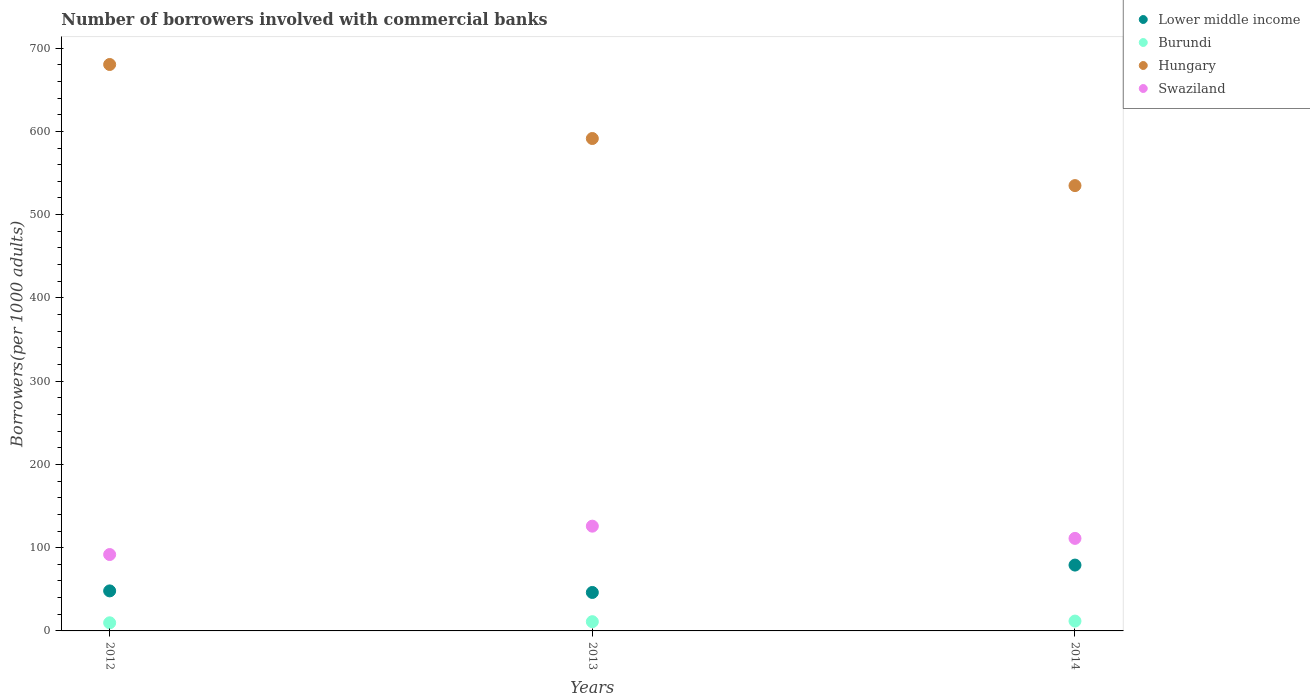What is the number of borrowers involved with commercial banks in Burundi in 2013?
Ensure brevity in your answer.  11.09. Across all years, what is the maximum number of borrowers involved with commercial banks in Lower middle income?
Provide a succinct answer. 79.08. Across all years, what is the minimum number of borrowers involved with commercial banks in Hungary?
Make the answer very short. 534.85. In which year was the number of borrowers involved with commercial banks in Swaziland minimum?
Your response must be concise. 2012. What is the total number of borrowers involved with commercial banks in Hungary in the graph?
Ensure brevity in your answer.  1806.59. What is the difference between the number of borrowers involved with commercial banks in Swaziland in 2012 and that in 2014?
Offer a very short reply. -19.4. What is the difference between the number of borrowers involved with commercial banks in Lower middle income in 2013 and the number of borrowers involved with commercial banks in Hungary in 2012?
Ensure brevity in your answer.  -634.13. What is the average number of borrowers involved with commercial banks in Hungary per year?
Your response must be concise. 602.2. In the year 2012, what is the difference between the number of borrowers involved with commercial banks in Burundi and number of borrowers involved with commercial banks in Hungary?
Provide a short and direct response. -670.57. In how many years, is the number of borrowers involved with commercial banks in Burundi greater than 320?
Ensure brevity in your answer.  0. What is the ratio of the number of borrowers involved with commercial banks in Hungary in 2012 to that in 2014?
Offer a very short reply. 1.27. Is the number of borrowers involved with commercial banks in Lower middle income in 2013 less than that in 2014?
Your answer should be very brief. Yes. Is the difference between the number of borrowers involved with commercial banks in Burundi in 2012 and 2013 greater than the difference between the number of borrowers involved with commercial banks in Hungary in 2012 and 2013?
Make the answer very short. No. What is the difference between the highest and the second highest number of borrowers involved with commercial banks in Burundi?
Your answer should be compact. 0.73. What is the difference between the highest and the lowest number of borrowers involved with commercial banks in Burundi?
Provide a short and direct response. 2.07. In how many years, is the number of borrowers involved with commercial banks in Lower middle income greater than the average number of borrowers involved with commercial banks in Lower middle income taken over all years?
Your answer should be very brief. 1. Is the sum of the number of borrowers involved with commercial banks in Swaziland in 2012 and 2014 greater than the maximum number of borrowers involved with commercial banks in Hungary across all years?
Ensure brevity in your answer.  No. Is it the case that in every year, the sum of the number of borrowers involved with commercial banks in Burundi and number of borrowers involved with commercial banks in Hungary  is greater than the number of borrowers involved with commercial banks in Swaziland?
Keep it short and to the point. Yes. Does the number of borrowers involved with commercial banks in Lower middle income monotonically increase over the years?
Provide a short and direct response. No. How many years are there in the graph?
Make the answer very short. 3. What is the difference between two consecutive major ticks on the Y-axis?
Keep it short and to the point. 100. Does the graph contain any zero values?
Give a very brief answer. No. Where does the legend appear in the graph?
Keep it short and to the point. Top right. How many legend labels are there?
Your answer should be very brief. 4. How are the legend labels stacked?
Provide a short and direct response. Vertical. What is the title of the graph?
Ensure brevity in your answer.  Number of borrowers involved with commercial banks. Does "Channel Islands" appear as one of the legend labels in the graph?
Ensure brevity in your answer.  No. What is the label or title of the X-axis?
Provide a short and direct response. Years. What is the label or title of the Y-axis?
Offer a terse response. Borrowers(per 1000 adults). What is the Borrowers(per 1000 adults) in Lower middle income in 2012?
Your answer should be very brief. 48.08. What is the Borrowers(per 1000 adults) in Burundi in 2012?
Provide a succinct answer. 9.75. What is the Borrowers(per 1000 adults) of Hungary in 2012?
Your answer should be very brief. 680.32. What is the Borrowers(per 1000 adults) of Swaziland in 2012?
Make the answer very short. 91.75. What is the Borrowers(per 1000 adults) of Lower middle income in 2013?
Keep it short and to the point. 46.19. What is the Borrowers(per 1000 adults) in Burundi in 2013?
Make the answer very short. 11.09. What is the Borrowers(per 1000 adults) of Hungary in 2013?
Make the answer very short. 591.42. What is the Borrowers(per 1000 adults) of Swaziland in 2013?
Your response must be concise. 125.82. What is the Borrowers(per 1000 adults) in Lower middle income in 2014?
Ensure brevity in your answer.  79.08. What is the Borrowers(per 1000 adults) of Burundi in 2014?
Your response must be concise. 11.82. What is the Borrowers(per 1000 adults) of Hungary in 2014?
Make the answer very short. 534.85. What is the Borrowers(per 1000 adults) in Swaziland in 2014?
Provide a succinct answer. 111.14. Across all years, what is the maximum Borrowers(per 1000 adults) of Lower middle income?
Offer a very short reply. 79.08. Across all years, what is the maximum Borrowers(per 1000 adults) in Burundi?
Give a very brief answer. 11.82. Across all years, what is the maximum Borrowers(per 1000 adults) in Hungary?
Keep it short and to the point. 680.32. Across all years, what is the maximum Borrowers(per 1000 adults) in Swaziland?
Provide a succinct answer. 125.82. Across all years, what is the minimum Borrowers(per 1000 adults) in Lower middle income?
Your answer should be very brief. 46.19. Across all years, what is the minimum Borrowers(per 1000 adults) in Burundi?
Make the answer very short. 9.75. Across all years, what is the minimum Borrowers(per 1000 adults) in Hungary?
Make the answer very short. 534.85. Across all years, what is the minimum Borrowers(per 1000 adults) of Swaziland?
Offer a very short reply. 91.75. What is the total Borrowers(per 1000 adults) in Lower middle income in the graph?
Provide a succinct answer. 173.35. What is the total Borrowers(per 1000 adults) in Burundi in the graph?
Provide a short and direct response. 32.66. What is the total Borrowers(per 1000 adults) in Hungary in the graph?
Provide a short and direct response. 1806.59. What is the total Borrowers(per 1000 adults) in Swaziland in the graph?
Make the answer very short. 328.71. What is the difference between the Borrowers(per 1000 adults) in Lower middle income in 2012 and that in 2013?
Your response must be concise. 1.89. What is the difference between the Borrowers(per 1000 adults) in Burundi in 2012 and that in 2013?
Provide a succinct answer. -1.34. What is the difference between the Borrowers(per 1000 adults) in Hungary in 2012 and that in 2013?
Provide a short and direct response. 88.9. What is the difference between the Borrowers(per 1000 adults) in Swaziland in 2012 and that in 2013?
Provide a short and direct response. -34.08. What is the difference between the Borrowers(per 1000 adults) in Lower middle income in 2012 and that in 2014?
Make the answer very short. -31. What is the difference between the Borrowers(per 1000 adults) in Burundi in 2012 and that in 2014?
Your response must be concise. -2.07. What is the difference between the Borrowers(per 1000 adults) in Hungary in 2012 and that in 2014?
Ensure brevity in your answer.  145.46. What is the difference between the Borrowers(per 1000 adults) of Swaziland in 2012 and that in 2014?
Your answer should be very brief. -19.4. What is the difference between the Borrowers(per 1000 adults) in Lower middle income in 2013 and that in 2014?
Provide a succinct answer. -32.89. What is the difference between the Borrowers(per 1000 adults) of Burundi in 2013 and that in 2014?
Provide a succinct answer. -0.73. What is the difference between the Borrowers(per 1000 adults) of Hungary in 2013 and that in 2014?
Your answer should be very brief. 56.56. What is the difference between the Borrowers(per 1000 adults) of Swaziland in 2013 and that in 2014?
Your answer should be compact. 14.68. What is the difference between the Borrowers(per 1000 adults) of Lower middle income in 2012 and the Borrowers(per 1000 adults) of Burundi in 2013?
Offer a very short reply. 36.99. What is the difference between the Borrowers(per 1000 adults) of Lower middle income in 2012 and the Borrowers(per 1000 adults) of Hungary in 2013?
Offer a very short reply. -543.34. What is the difference between the Borrowers(per 1000 adults) in Lower middle income in 2012 and the Borrowers(per 1000 adults) in Swaziland in 2013?
Ensure brevity in your answer.  -77.74. What is the difference between the Borrowers(per 1000 adults) of Burundi in 2012 and the Borrowers(per 1000 adults) of Hungary in 2013?
Provide a succinct answer. -581.67. What is the difference between the Borrowers(per 1000 adults) in Burundi in 2012 and the Borrowers(per 1000 adults) in Swaziland in 2013?
Ensure brevity in your answer.  -116.07. What is the difference between the Borrowers(per 1000 adults) of Hungary in 2012 and the Borrowers(per 1000 adults) of Swaziland in 2013?
Your answer should be very brief. 554.5. What is the difference between the Borrowers(per 1000 adults) in Lower middle income in 2012 and the Borrowers(per 1000 adults) in Burundi in 2014?
Your response must be concise. 36.26. What is the difference between the Borrowers(per 1000 adults) in Lower middle income in 2012 and the Borrowers(per 1000 adults) in Hungary in 2014?
Offer a terse response. -486.78. What is the difference between the Borrowers(per 1000 adults) in Lower middle income in 2012 and the Borrowers(per 1000 adults) in Swaziland in 2014?
Offer a terse response. -63.06. What is the difference between the Borrowers(per 1000 adults) in Burundi in 2012 and the Borrowers(per 1000 adults) in Hungary in 2014?
Offer a very short reply. -525.1. What is the difference between the Borrowers(per 1000 adults) of Burundi in 2012 and the Borrowers(per 1000 adults) of Swaziland in 2014?
Your answer should be compact. -101.39. What is the difference between the Borrowers(per 1000 adults) in Hungary in 2012 and the Borrowers(per 1000 adults) in Swaziland in 2014?
Give a very brief answer. 569.18. What is the difference between the Borrowers(per 1000 adults) of Lower middle income in 2013 and the Borrowers(per 1000 adults) of Burundi in 2014?
Provide a succinct answer. 34.37. What is the difference between the Borrowers(per 1000 adults) in Lower middle income in 2013 and the Borrowers(per 1000 adults) in Hungary in 2014?
Your response must be concise. -488.66. What is the difference between the Borrowers(per 1000 adults) in Lower middle income in 2013 and the Borrowers(per 1000 adults) in Swaziland in 2014?
Make the answer very short. -64.95. What is the difference between the Borrowers(per 1000 adults) in Burundi in 2013 and the Borrowers(per 1000 adults) in Hungary in 2014?
Your response must be concise. -523.77. What is the difference between the Borrowers(per 1000 adults) in Burundi in 2013 and the Borrowers(per 1000 adults) in Swaziland in 2014?
Offer a terse response. -100.05. What is the difference between the Borrowers(per 1000 adults) of Hungary in 2013 and the Borrowers(per 1000 adults) of Swaziland in 2014?
Your answer should be compact. 480.28. What is the average Borrowers(per 1000 adults) in Lower middle income per year?
Your answer should be compact. 57.78. What is the average Borrowers(per 1000 adults) of Burundi per year?
Your response must be concise. 10.89. What is the average Borrowers(per 1000 adults) in Hungary per year?
Your response must be concise. 602.2. What is the average Borrowers(per 1000 adults) in Swaziland per year?
Provide a short and direct response. 109.57. In the year 2012, what is the difference between the Borrowers(per 1000 adults) of Lower middle income and Borrowers(per 1000 adults) of Burundi?
Ensure brevity in your answer.  38.33. In the year 2012, what is the difference between the Borrowers(per 1000 adults) in Lower middle income and Borrowers(per 1000 adults) in Hungary?
Offer a terse response. -632.24. In the year 2012, what is the difference between the Borrowers(per 1000 adults) in Lower middle income and Borrowers(per 1000 adults) in Swaziland?
Your response must be concise. -43.67. In the year 2012, what is the difference between the Borrowers(per 1000 adults) of Burundi and Borrowers(per 1000 adults) of Hungary?
Your response must be concise. -670.57. In the year 2012, what is the difference between the Borrowers(per 1000 adults) in Burundi and Borrowers(per 1000 adults) in Swaziland?
Offer a very short reply. -82. In the year 2012, what is the difference between the Borrowers(per 1000 adults) of Hungary and Borrowers(per 1000 adults) of Swaziland?
Offer a terse response. 588.57. In the year 2013, what is the difference between the Borrowers(per 1000 adults) in Lower middle income and Borrowers(per 1000 adults) in Burundi?
Offer a very short reply. 35.1. In the year 2013, what is the difference between the Borrowers(per 1000 adults) in Lower middle income and Borrowers(per 1000 adults) in Hungary?
Your response must be concise. -545.22. In the year 2013, what is the difference between the Borrowers(per 1000 adults) in Lower middle income and Borrowers(per 1000 adults) in Swaziland?
Your answer should be very brief. -79.63. In the year 2013, what is the difference between the Borrowers(per 1000 adults) in Burundi and Borrowers(per 1000 adults) in Hungary?
Make the answer very short. -580.33. In the year 2013, what is the difference between the Borrowers(per 1000 adults) in Burundi and Borrowers(per 1000 adults) in Swaziland?
Offer a terse response. -114.73. In the year 2013, what is the difference between the Borrowers(per 1000 adults) in Hungary and Borrowers(per 1000 adults) in Swaziland?
Make the answer very short. 465.6. In the year 2014, what is the difference between the Borrowers(per 1000 adults) of Lower middle income and Borrowers(per 1000 adults) of Burundi?
Your answer should be compact. 67.26. In the year 2014, what is the difference between the Borrowers(per 1000 adults) in Lower middle income and Borrowers(per 1000 adults) in Hungary?
Provide a succinct answer. -455.77. In the year 2014, what is the difference between the Borrowers(per 1000 adults) in Lower middle income and Borrowers(per 1000 adults) in Swaziland?
Your answer should be compact. -32.06. In the year 2014, what is the difference between the Borrowers(per 1000 adults) in Burundi and Borrowers(per 1000 adults) in Hungary?
Ensure brevity in your answer.  -523.03. In the year 2014, what is the difference between the Borrowers(per 1000 adults) in Burundi and Borrowers(per 1000 adults) in Swaziland?
Give a very brief answer. -99.32. In the year 2014, what is the difference between the Borrowers(per 1000 adults) in Hungary and Borrowers(per 1000 adults) in Swaziland?
Ensure brevity in your answer.  423.71. What is the ratio of the Borrowers(per 1000 adults) in Lower middle income in 2012 to that in 2013?
Your answer should be very brief. 1.04. What is the ratio of the Borrowers(per 1000 adults) in Burundi in 2012 to that in 2013?
Provide a succinct answer. 0.88. What is the ratio of the Borrowers(per 1000 adults) of Hungary in 2012 to that in 2013?
Ensure brevity in your answer.  1.15. What is the ratio of the Borrowers(per 1000 adults) in Swaziland in 2012 to that in 2013?
Ensure brevity in your answer.  0.73. What is the ratio of the Borrowers(per 1000 adults) in Lower middle income in 2012 to that in 2014?
Offer a terse response. 0.61. What is the ratio of the Borrowers(per 1000 adults) of Burundi in 2012 to that in 2014?
Your answer should be very brief. 0.82. What is the ratio of the Borrowers(per 1000 adults) of Hungary in 2012 to that in 2014?
Offer a terse response. 1.27. What is the ratio of the Borrowers(per 1000 adults) of Swaziland in 2012 to that in 2014?
Give a very brief answer. 0.83. What is the ratio of the Borrowers(per 1000 adults) of Lower middle income in 2013 to that in 2014?
Provide a succinct answer. 0.58. What is the ratio of the Borrowers(per 1000 adults) of Burundi in 2013 to that in 2014?
Your answer should be compact. 0.94. What is the ratio of the Borrowers(per 1000 adults) in Hungary in 2013 to that in 2014?
Your response must be concise. 1.11. What is the ratio of the Borrowers(per 1000 adults) of Swaziland in 2013 to that in 2014?
Ensure brevity in your answer.  1.13. What is the difference between the highest and the second highest Borrowers(per 1000 adults) in Lower middle income?
Offer a terse response. 31. What is the difference between the highest and the second highest Borrowers(per 1000 adults) in Burundi?
Your answer should be compact. 0.73. What is the difference between the highest and the second highest Borrowers(per 1000 adults) of Hungary?
Your answer should be compact. 88.9. What is the difference between the highest and the second highest Borrowers(per 1000 adults) in Swaziland?
Offer a terse response. 14.68. What is the difference between the highest and the lowest Borrowers(per 1000 adults) of Lower middle income?
Your answer should be very brief. 32.89. What is the difference between the highest and the lowest Borrowers(per 1000 adults) in Burundi?
Provide a succinct answer. 2.07. What is the difference between the highest and the lowest Borrowers(per 1000 adults) in Hungary?
Your response must be concise. 145.46. What is the difference between the highest and the lowest Borrowers(per 1000 adults) of Swaziland?
Keep it short and to the point. 34.08. 